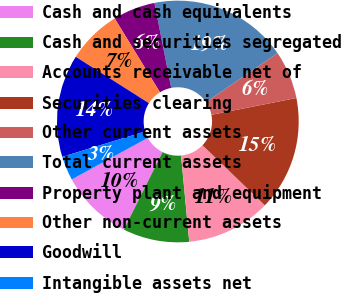<chart> <loc_0><loc_0><loc_500><loc_500><pie_chart><fcel>Cash and cash equivalents<fcel>Cash and securities segregated<fcel>Accounts receivable net of<fcel>Securities clearing<fcel>Other current assets<fcel>Total current assets<fcel>Property plant and equipment<fcel>Other non-current assets<fcel>Goodwill<fcel>Intangible assets net<nl><fcel>9.68%<fcel>8.87%<fcel>11.29%<fcel>15.32%<fcel>6.45%<fcel>18.54%<fcel>5.65%<fcel>7.26%<fcel>13.71%<fcel>3.23%<nl></chart> 